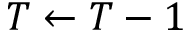<formula> <loc_0><loc_0><loc_500><loc_500>T \gets T - 1</formula> 